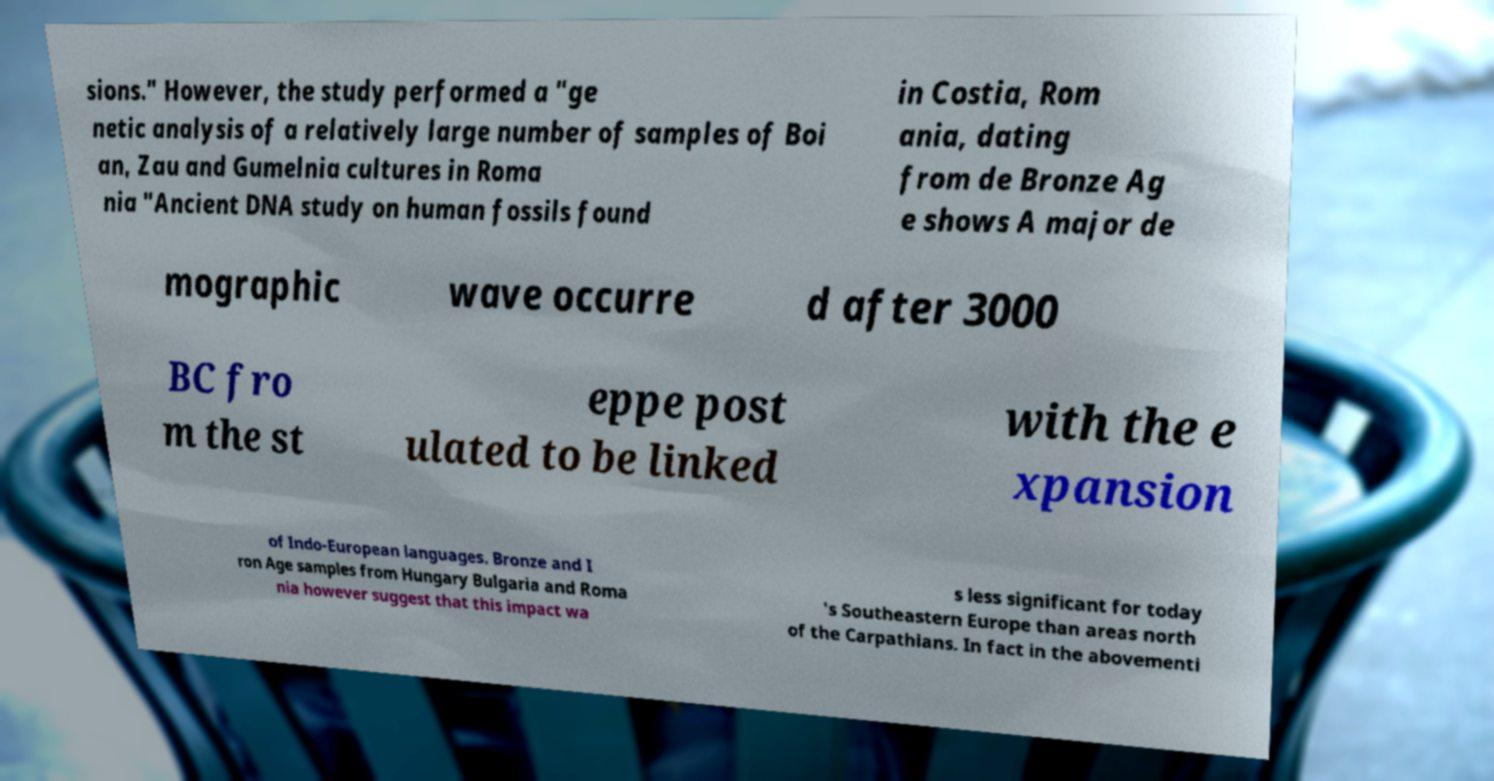I need the written content from this picture converted into text. Can you do that? sions." However, the study performed a "ge netic analysis of a relatively large number of samples of Boi an, Zau and Gumelnia cultures in Roma nia "Ancient DNA study on human fossils found in Costia, Rom ania, dating from de Bronze Ag e shows A major de mographic wave occurre d after 3000 BC fro m the st eppe post ulated to be linked with the e xpansion of Indo-European languages. Bronze and I ron Age samples from Hungary Bulgaria and Roma nia however suggest that this impact wa s less significant for today 's Southeastern Europe than areas north of the Carpathians. In fact in the abovementi 